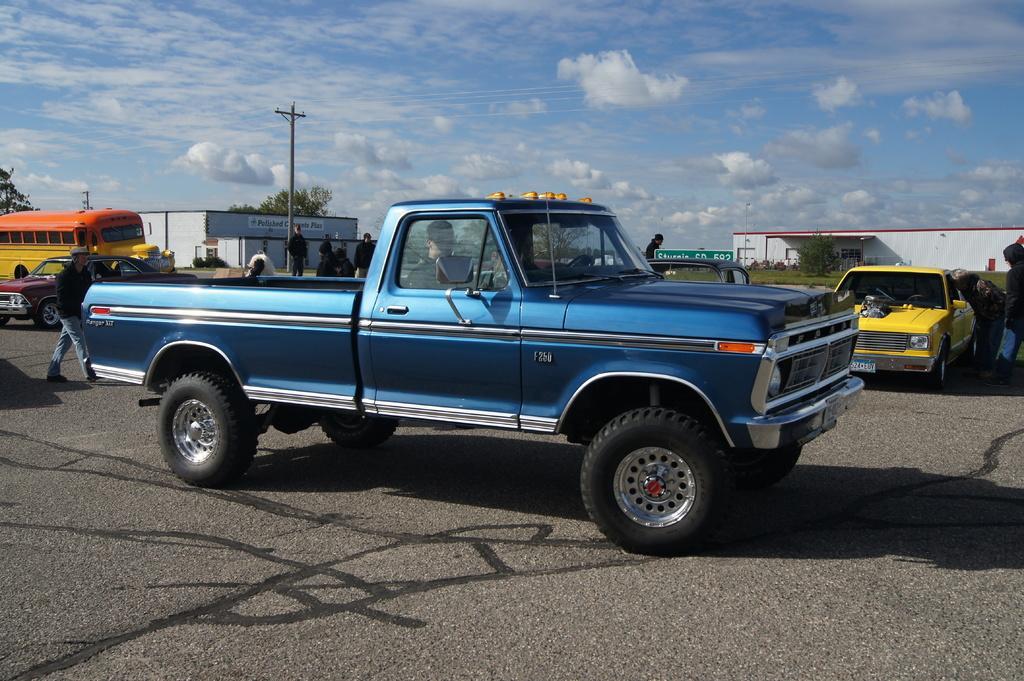Please provide a concise description of this image. In this image we can see vehicles on the road, beside that we can see few people walking, we can see text written on the board. And we can see sheds, we can see an electrical pole, beside that we can see trees and grass. And we can see the sky with clouds. 